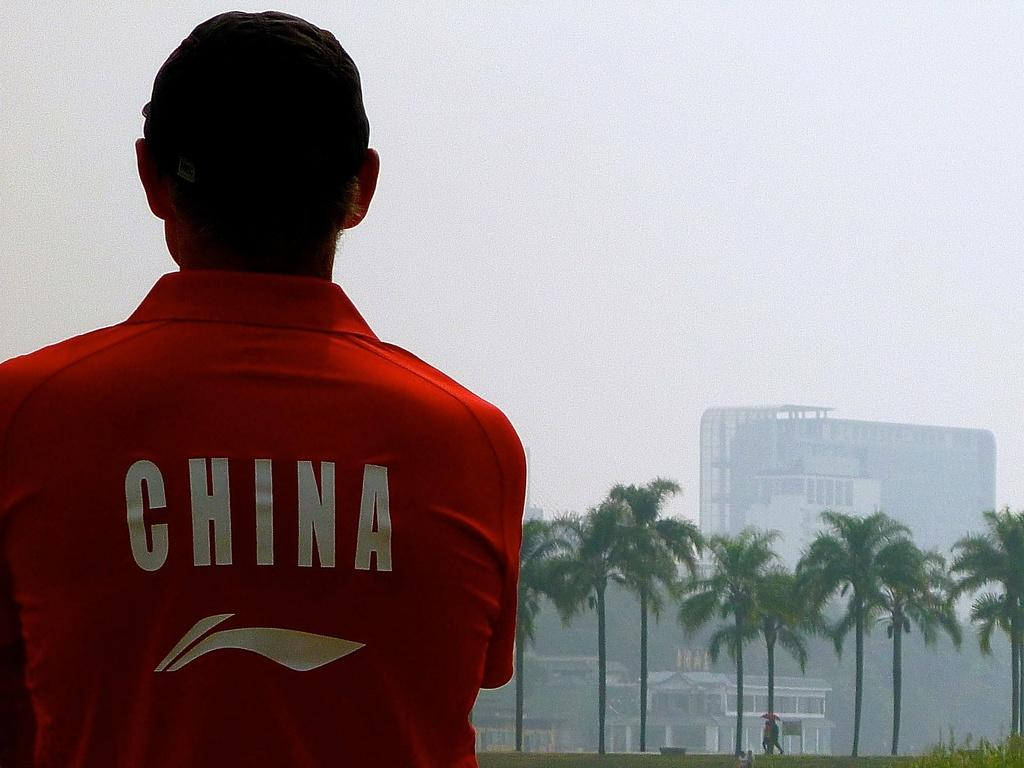<image>
Create a compact narrative representing the image presented. A man wearing a red China shirt looking at palm trees. 